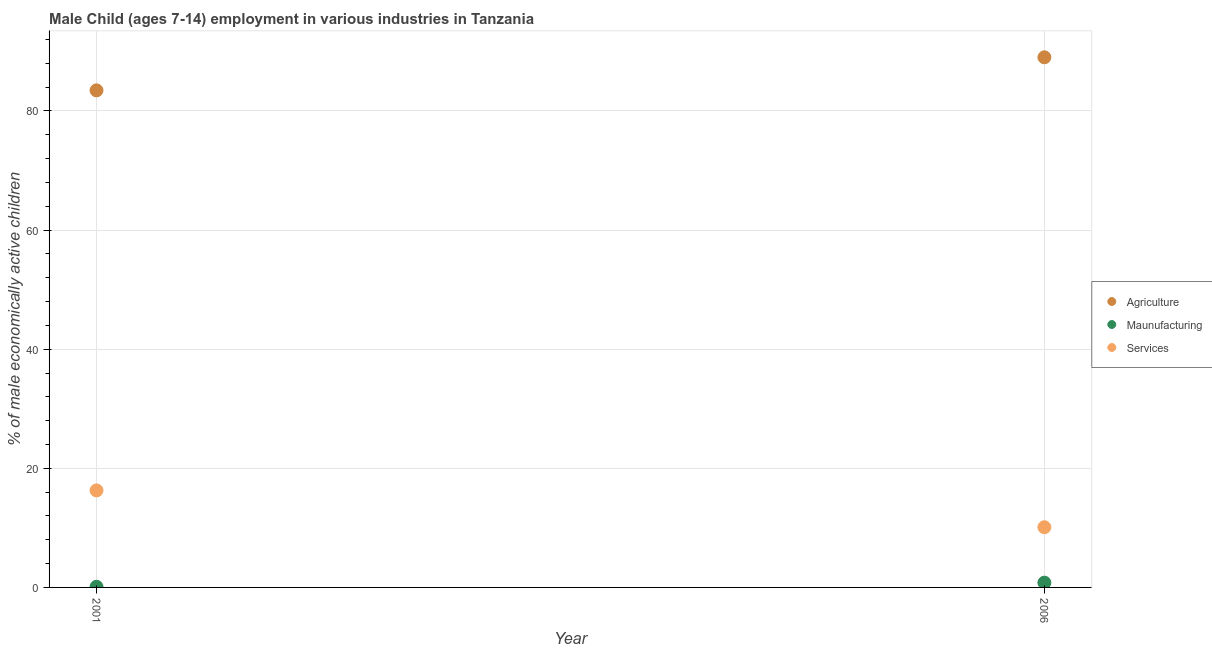How many different coloured dotlines are there?
Your answer should be compact. 3. What is the percentage of economically active children in agriculture in 2006?
Make the answer very short. 89.01. Across all years, what is the maximum percentage of economically active children in manufacturing?
Keep it short and to the point. 0.8. Across all years, what is the minimum percentage of economically active children in agriculture?
Your answer should be compact. 83.46. What is the total percentage of economically active children in manufacturing in the graph?
Provide a short and direct response. 0.91. What is the difference between the percentage of economically active children in manufacturing in 2001 and that in 2006?
Offer a very short reply. -0.69. What is the difference between the percentage of economically active children in manufacturing in 2001 and the percentage of economically active children in agriculture in 2006?
Provide a succinct answer. -88.9. What is the average percentage of economically active children in services per year?
Your answer should be compact. 13.2. In the year 2001, what is the difference between the percentage of economically active children in manufacturing and percentage of economically active children in services?
Your answer should be very brief. -16.18. In how many years, is the percentage of economically active children in services greater than 12 %?
Give a very brief answer. 1. What is the ratio of the percentage of economically active children in manufacturing in 2001 to that in 2006?
Make the answer very short. 0.13. Is the percentage of economically active children in manufacturing in 2001 less than that in 2006?
Keep it short and to the point. Yes. Is it the case that in every year, the sum of the percentage of economically active children in agriculture and percentage of economically active children in manufacturing is greater than the percentage of economically active children in services?
Offer a very short reply. Yes. Does the percentage of economically active children in manufacturing monotonically increase over the years?
Make the answer very short. Yes. How many dotlines are there?
Your answer should be very brief. 3. How many years are there in the graph?
Provide a short and direct response. 2. Are the values on the major ticks of Y-axis written in scientific E-notation?
Your answer should be compact. No. Does the graph contain any zero values?
Keep it short and to the point. No. Where does the legend appear in the graph?
Your answer should be very brief. Center right. How many legend labels are there?
Your answer should be compact. 3. What is the title of the graph?
Your response must be concise. Male Child (ages 7-14) employment in various industries in Tanzania. What is the label or title of the Y-axis?
Provide a succinct answer. % of male economically active children. What is the % of male economically active children of Agriculture in 2001?
Keep it short and to the point. 83.46. What is the % of male economically active children in Maunufacturing in 2001?
Ensure brevity in your answer.  0.11. What is the % of male economically active children of Services in 2001?
Provide a short and direct response. 16.29. What is the % of male economically active children in Agriculture in 2006?
Give a very brief answer. 89.01. What is the % of male economically active children in Maunufacturing in 2006?
Make the answer very short. 0.8. What is the % of male economically active children in Services in 2006?
Give a very brief answer. 10.11. Across all years, what is the maximum % of male economically active children of Agriculture?
Offer a terse response. 89.01. Across all years, what is the maximum % of male economically active children in Maunufacturing?
Provide a succinct answer. 0.8. Across all years, what is the maximum % of male economically active children of Services?
Offer a terse response. 16.29. Across all years, what is the minimum % of male economically active children in Agriculture?
Provide a short and direct response. 83.46. Across all years, what is the minimum % of male economically active children in Maunufacturing?
Your response must be concise. 0.11. Across all years, what is the minimum % of male economically active children in Services?
Your response must be concise. 10.11. What is the total % of male economically active children in Agriculture in the graph?
Your answer should be very brief. 172.47. What is the total % of male economically active children in Maunufacturing in the graph?
Offer a very short reply. 0.91. What is the total % of male economically active children of Services in the graph?
Offer a terse response. 26.4. What is the difference between the % of male economically active children of Agriculture in 2001 and that in 2006?
Ensure brevity in your answer.  -5.55. What is the difference between the % of male economically active children in Maunufacturing in 2001 and that in 2006?
Your response must be concise. -0.69. What is the difference between the % of male economically active children of Services in 2001 and that in 2006?
Give a very brief answer. 6.18. What is the difference between the % of male economically active children in Agriculture in 2001 and the % of male economically active children in Maunufacturing in 2006?
Ensure brevity in your answer.  82.66. What is the difference between the % of male economically active children in Agriculture in 2001 and the % of male economically active children in Services in 2006?
Provide a short and direct response. 73.35. What is the difference between the % of male economically active children of Maunufacturing in 2001 and the % of male economically active children of Services in 2006?
Keep it short and to the point. -10. What is the average % of male economically active children of Agriculture per year?
Keep it short and to the point. 86.23. What is the average % of male economically active children in Maunufacturing per year?
Provide a short and direct response. 0.45. What is the average % of male economically active children of Services per year?
Provide a succinct answer. 13.2. In the year 2001, what is the difference between the % of male economically active children of Agriculture and % of male economically active children of Maunufacturing?
Your answer should be compact. 83.35. In the year 2001, what is the difference between the % of male economically active children in Agriculture and % of male economically active children in Services?
Your response must be concise. 67.17. In the year 2001, what is the difference between the % of male economically active children of Maunufacturing and % of male economically active children of Services?
Provide a succinct answer. -16.18. In the year 2006, what is the difference between the % of male economically active children in Agriculture and % of male economically active children in Maunufacturing?
Your answer should be very brief. 88.21. In the year 2006, what is the difference between the % of male economically active children of Agriculture and % of male economically active children of Services?
Provide a short and direct response. 78.9. In the year 2006, what is the difference between the % of male economically active children in Maunufacturing and % of male economically active children in Services?
Offer a very short reply. -9.31. What is the ratio of the % of male economically active children of Agriculture in 2001 to that in 2006?
Ensure brevity in your answer.  0.94. What is the ratio of the % of male economically active children in Maunufacturing in 2001 to that in 2006?
Your response must be concise. 0.13. What is the ratio of the % of male economically active children in Services in 2001 to that in 2006?
Make the answer very short. 1.61. What is the difference between the highest and the second highest % of male economically active children of Agriculture?
Give a very brief answer. 5.55. What is the difference between the highest and the second highest % of male economically active children of Maunufacturing?
Offer a terse response. 0.69. What is the difference between the highest and the second highest % of male economically active children of Services?
Offer a terse response. 6.18. What is the difference between the highest and the lowest % of male economically active children of Agriculture?
Ensure brevity in your answer.  5.55. What is the difference between the highest and the lowest % of male economically active children of Maunufacturing?
Offer a very short reply. 0.69. What is the difference between the highest and the lowest % of male economically active children in Services?
Your answer should be very brief. 6.18. 